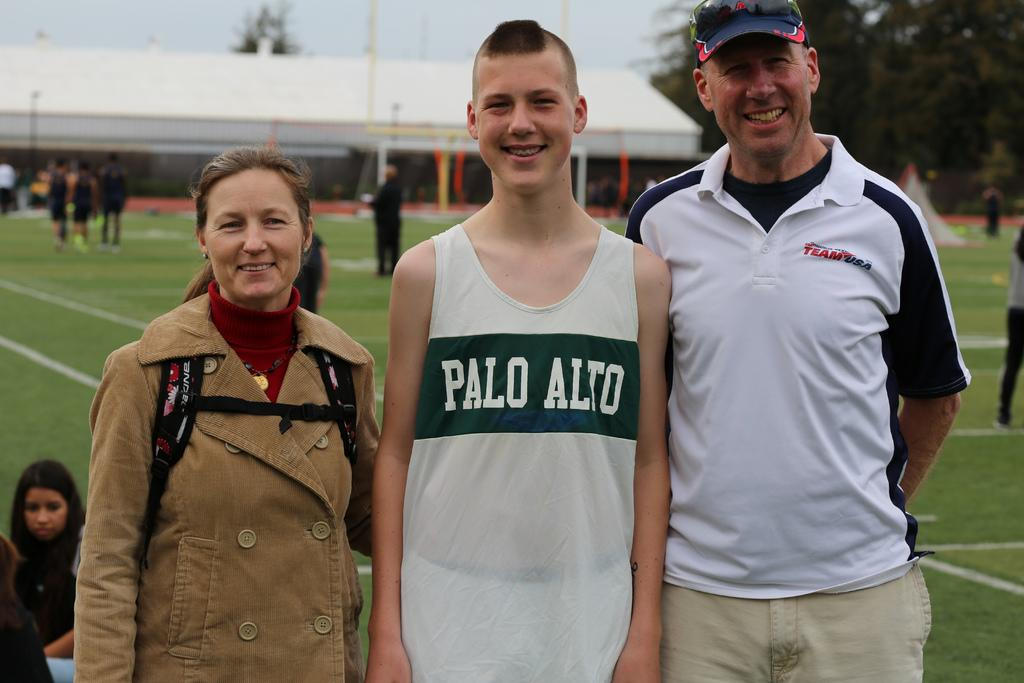<image>
Write a terse but informative summary of the picture. A man and woman stand either side of a young man who is wearing a Palo Alto vest. 